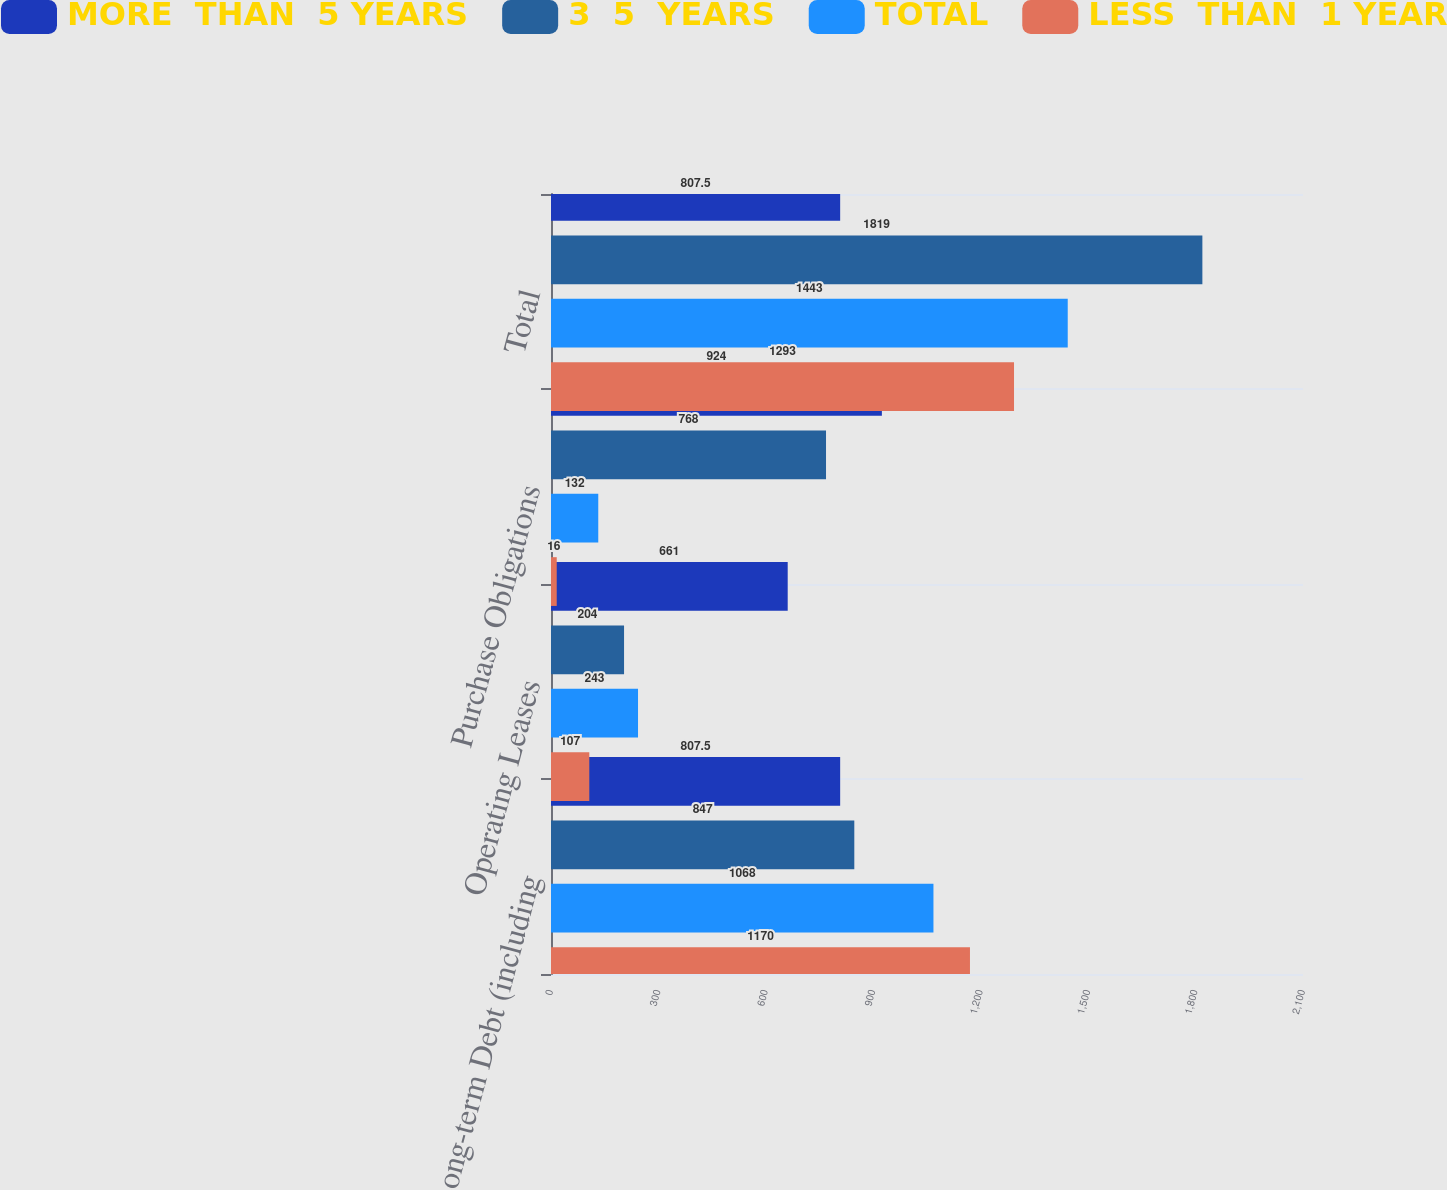Convert chart. <chart><loc_0><loc_0><loc_500><loc_500><stacked_bar_chart><ecel><fcel>Long-term Debt (including<fcel>Operating Leases<fcel>Purchase Obligations<fcel>Total<nl><fcel>MORE  THAN  5 YEARS<fcel>807.5<fcel>661<fcel>924<fcel>807.5<nl><fcel>3  5  YEARS<fcel>847<fcel>204<fcel>768<fcel>1819<nl><fcel>TOTAL<fcel>1068<fcel>243<fcel>132<fcel>1443<nl><fcel>LESS  THAN  1 YEAR<fcel>1170<fcel>107<fcel>16<fcel>1293<nl></chart> 